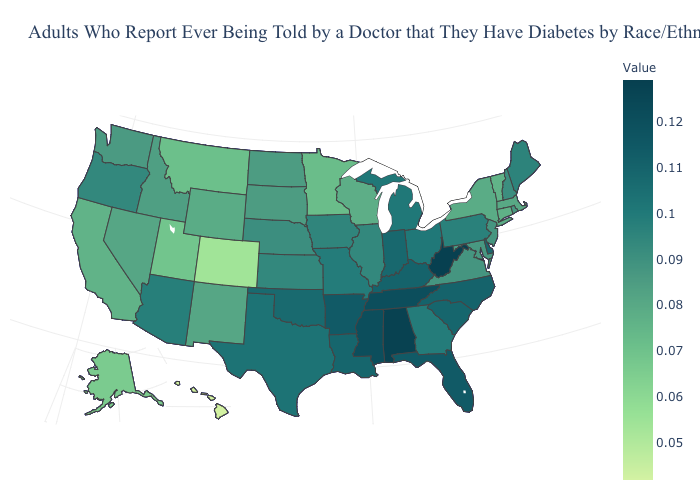Among the states that border California , which have the highest value?
Give a very brief answer. Arizona. Does the map have missing data?
Concise answer only. No. Which states have the highest value in the USA?
Short answer required. West Virginia. Does Hawaii have the lowest value in the USA?
Write a very short answer. Yes. Does Arizona have the highest value in the West?
Short answer required. Yes. Does Nebraska have the lowest value in the USA?
Be succinct. No. Does Alabama have the highest value in the South?
Answer briefly. No. 